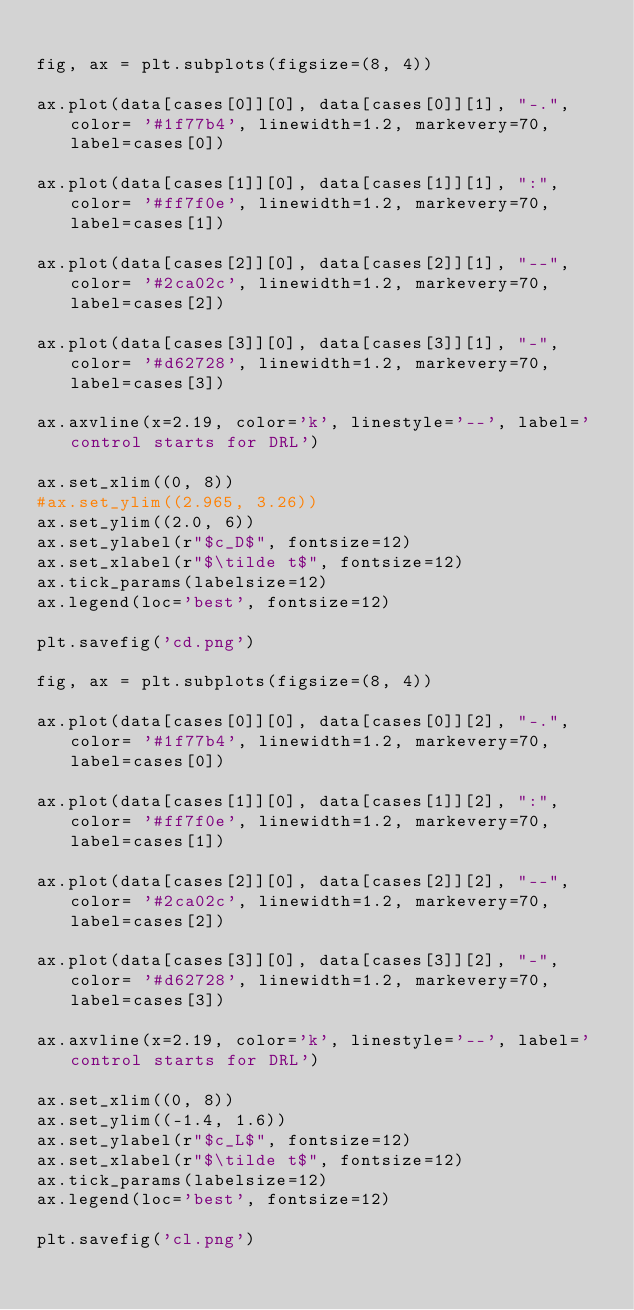<code> <loc_0><loc_0><loc_500><loc_500><_Python_>
fig, ax = plt.subplots(figsize=(8, 4))

ax.plot(data[cases[0]][0], data[cases[0]][1], "-.", color= '#1f77b4', linewidth=1.2, markevery=70, label=cases[0])

ax.plot(data[cases[1]][0], data[cases[1]][1], ":", color= '#ff7f0e', linewidth=1.2, markevery=70, label=cases[1])

ax.plot(data[cases[2]][0], data[cases[2]][1], "--", color= '#2ca02c', linewidth=1.2, markevery=70, label=cases[2])

ax.plot(data[cases[3]][0], data[cases[3]][1], "-", color= '#d62728', linewidth=1.2, markevery=70, label=cases[3])

ax.axvline(x=2.19, color='k', linestyle='--', label='control starts for DRL')

ax.set_xlim((0, 8))
#ax.set_ylim((2.965, 3.26))
ax.set_ylim((2.0, 6))
ax.set_ylabel(r"$c_D$", fontsize=12)
ax.set_xlabel(r"$\tilde t$", fontsize=12)
ax.tick_params(labelsize=12)
ax.legend(loc='best', fontsize=12)

plt.savefig('cd.png')

fig, ax = plt.subplots(figsize=(8, 4))

ax.plot(data[cases[0]][0], data[cases[0]][2], "-.", color= '#1f77b4', linewidth=1.2, markevery=70, label=cases[0])

ax.plot(data[cases[1]][0], data[cases[1]][2], ":", color= '#ff7f0e', linewidth=1.2, markevery=70, label=cases[1])

ax.plot(data[cases[2]][0], data[cases[2]][2], "--", color= '#2ca02c', linewidth=1.2, markevery=70, label=cases[2])

ax.plot(data[cases[3]][0], data[cases[3]][2], "-", color= '#d62728', linewidth=1.2, markevery=70, label=cases[3])

ax.axvline(x=2.19, color='k', linestyle='--', label='control starts for DRL')

ax.set_xlim((0, 8))
ax.set_ylim((-1.4, 1.6))
ax.set_ylabel(r"$c_L$", fontsize=12)
ax.set_xlabel(r"$\tilde t$", fontsize=12)
ax.tick_params(labelsize=12)
ax.legend(loc='best', fontsize=12)

plt.savefig('cl.png')
</code> 